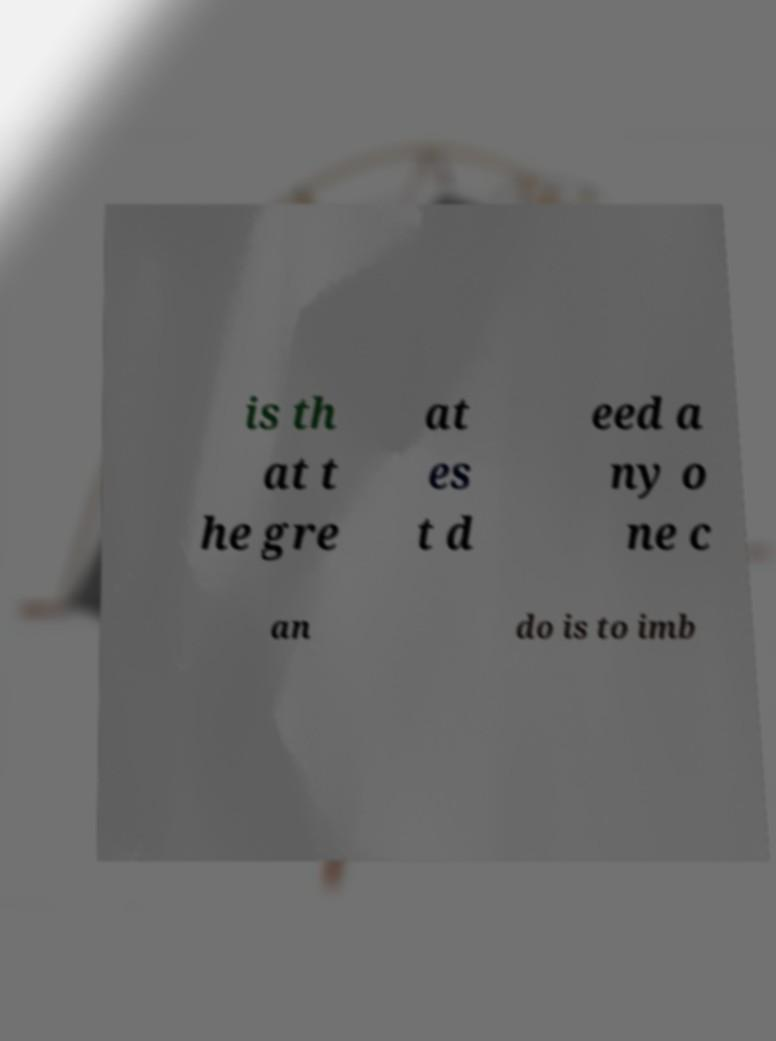For documentation purposes, I need the text within this image transcribed. Could you provide that? is th at t he gre at es t d eed a ny o ne c an do is to imb 